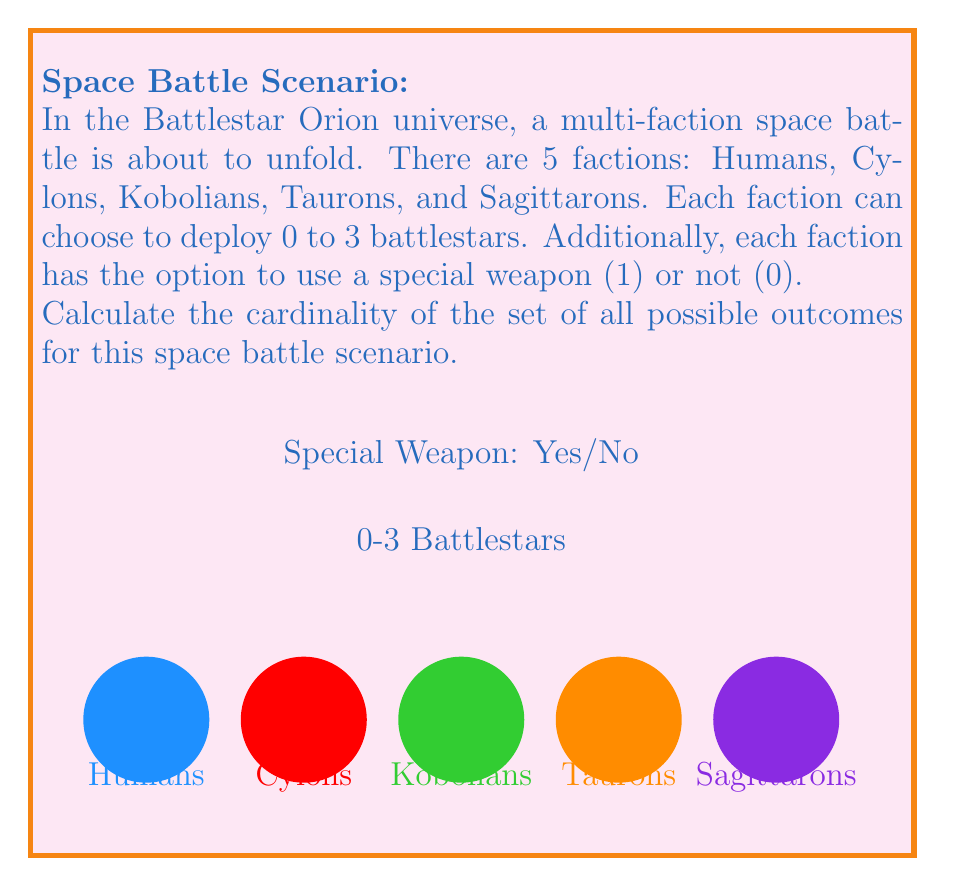Teach me how to tackle this problem. Let's break this down step-by-step:

1) For each faction, we need to consider two independent choices:
   a) Number of battlestars (0 to 3): 4 possibilities
   b) Special weapon use (0 or 1): 2 possibilities

2) For a single faction, the number of possible outcomes is:
   $4 \times 2 = 8$

3) Since there are 5 factions, and each faction's choice is independent of the others, we can use the multiplication principle of counting.

4) The total number of possible outcomes is:
   $8^5 = (4 \times 2)^5$

5) Let's calculate this:
   $$(4 \times 2)^5 = 8^5 = 32,768$$

6) Therefore, the cardinality of the set of all possible outcomes is 32,768.

This large number represents all the different combinations of battlestar deployments and special weapon usage across all five factions in this Battlestar Orion-inspired scenario.
Answer: $$32,768$$ 